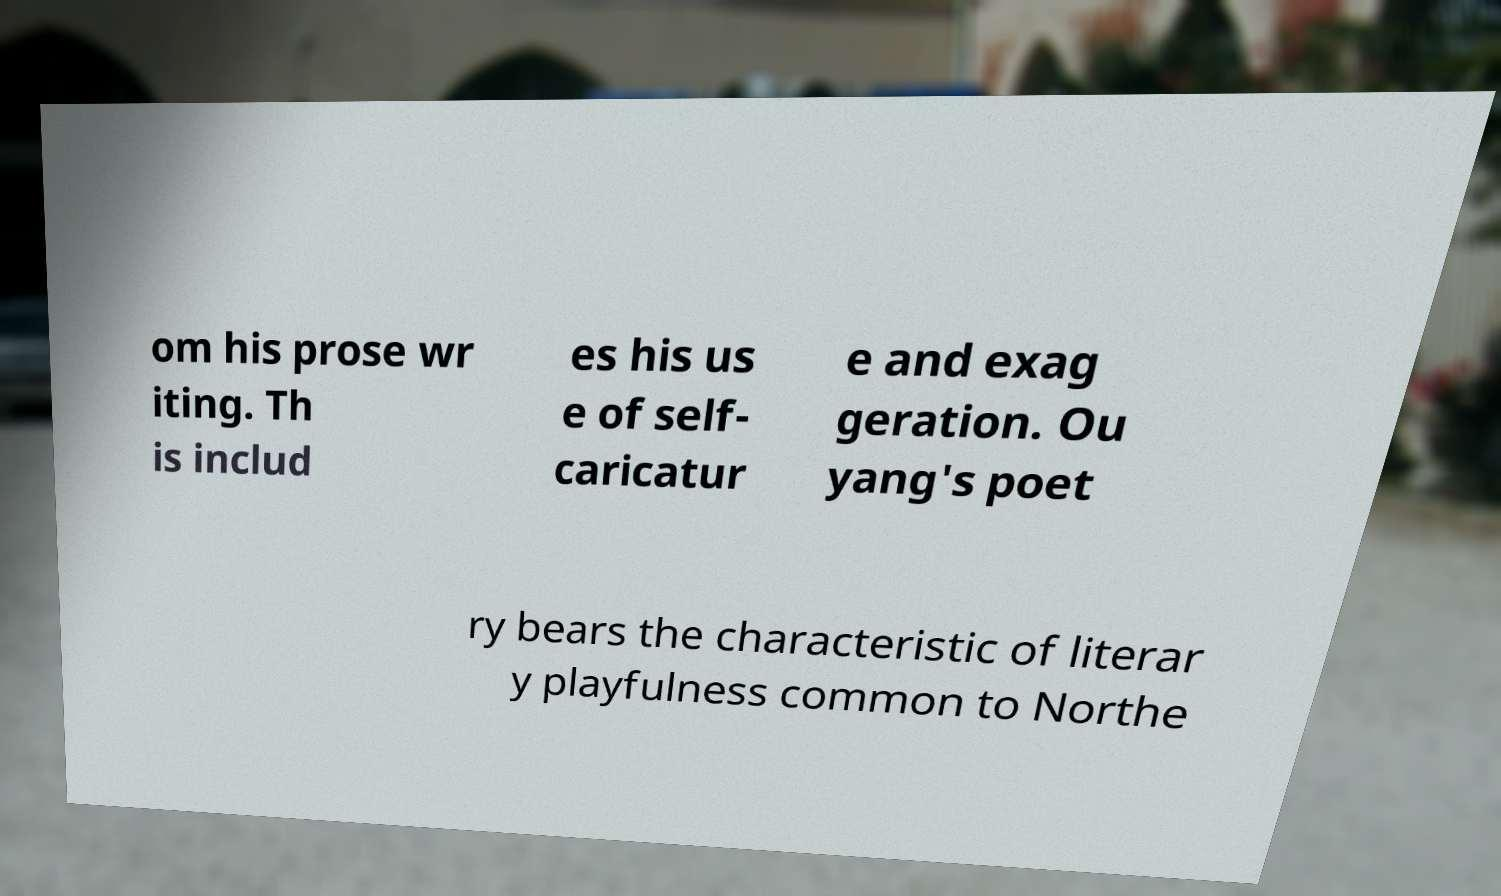I need the written content from this picture converted into text. Can you do that? om his prose wr iting. Th is includ es his us e of self- caricatur e and exag geration. Ou yang's poet ry bears the characteristic of literar y playfulness common to Northe 